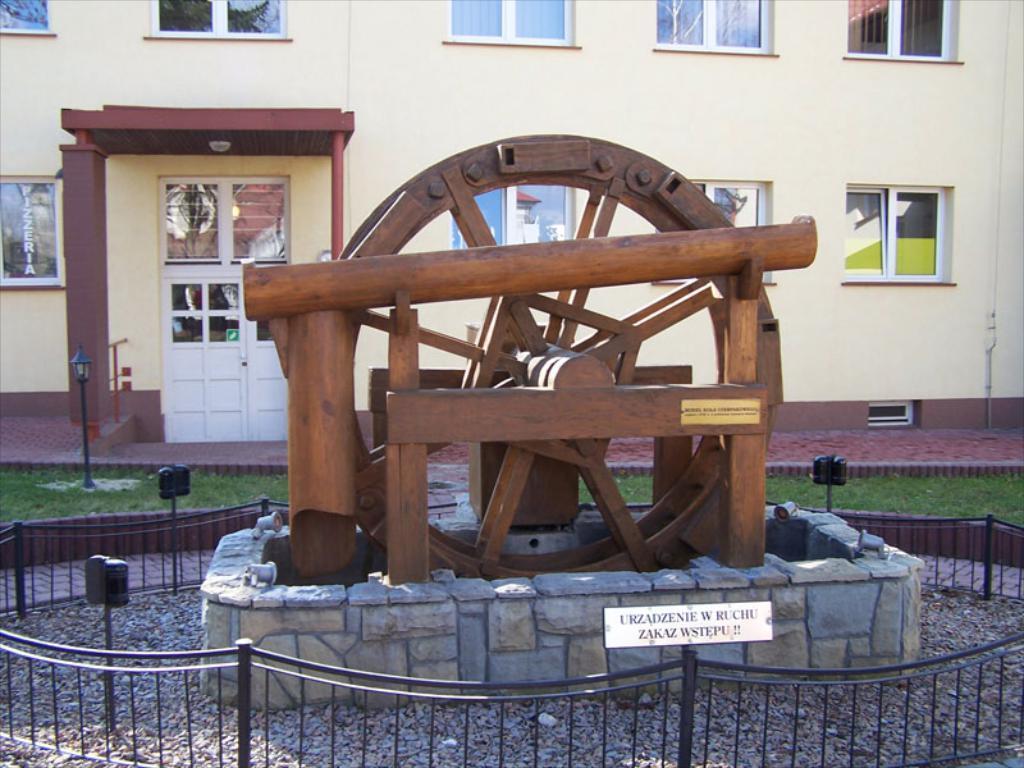Describe this image in one or two sentences. In this image we can see a wooden wheel and some stones inside a barricade. On the backside we can see a building with windows and a street lamp. 